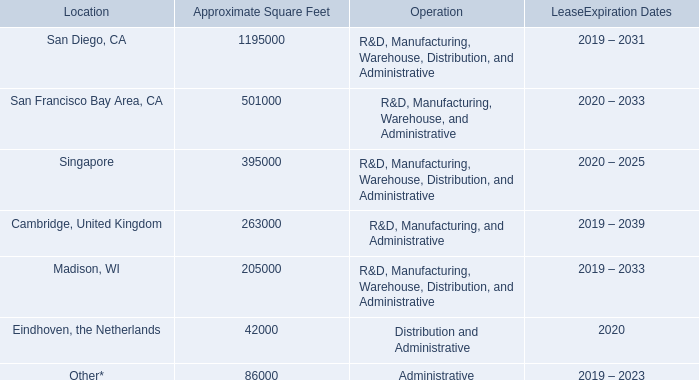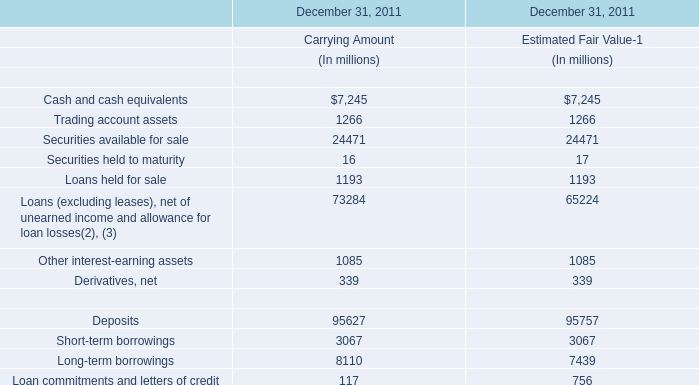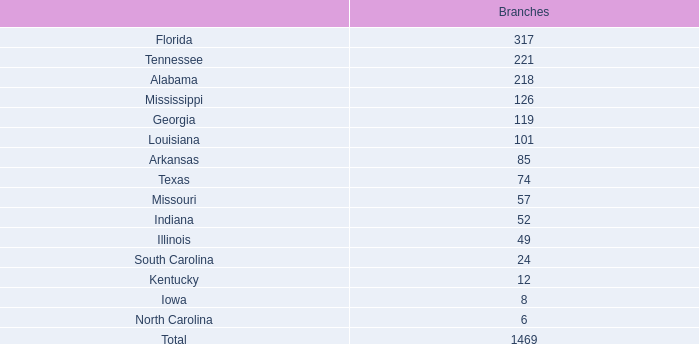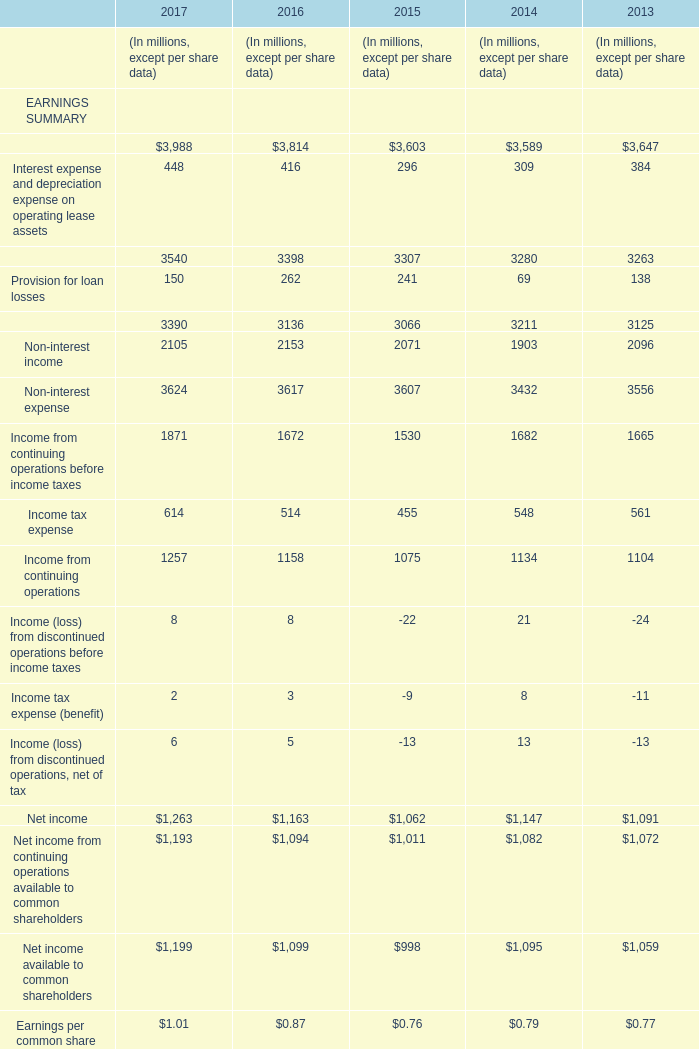In which year is Interest income, including other financing income positive? 
Answer: 2017 2016 2015 2014 2013. 